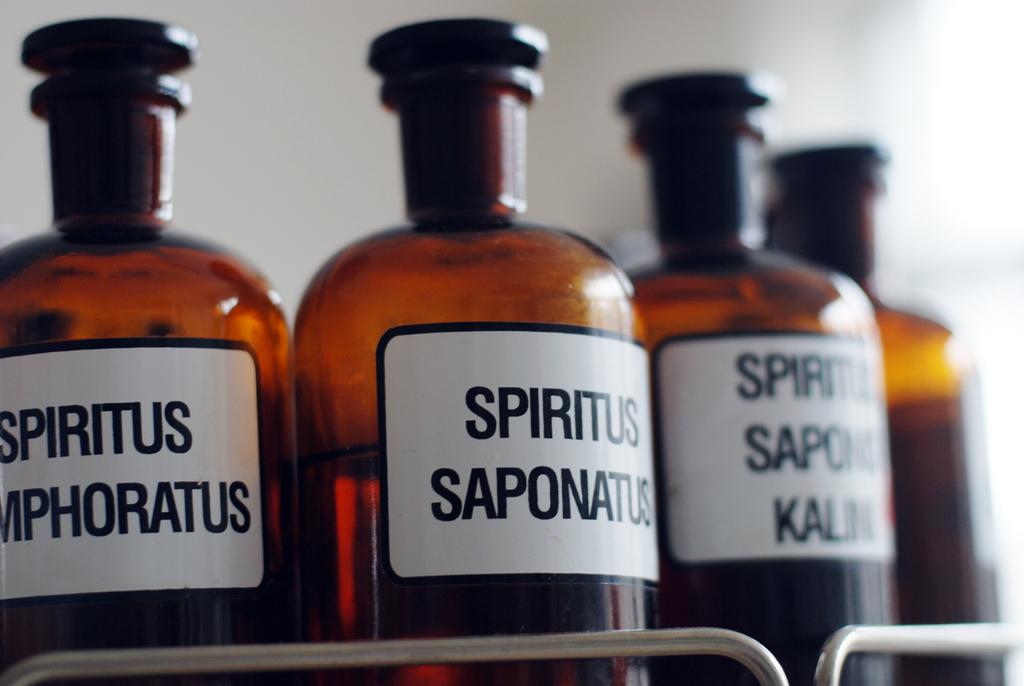What is in the bottle on the front, right?
Provide a succinct answer. Spiritus saponatus. 